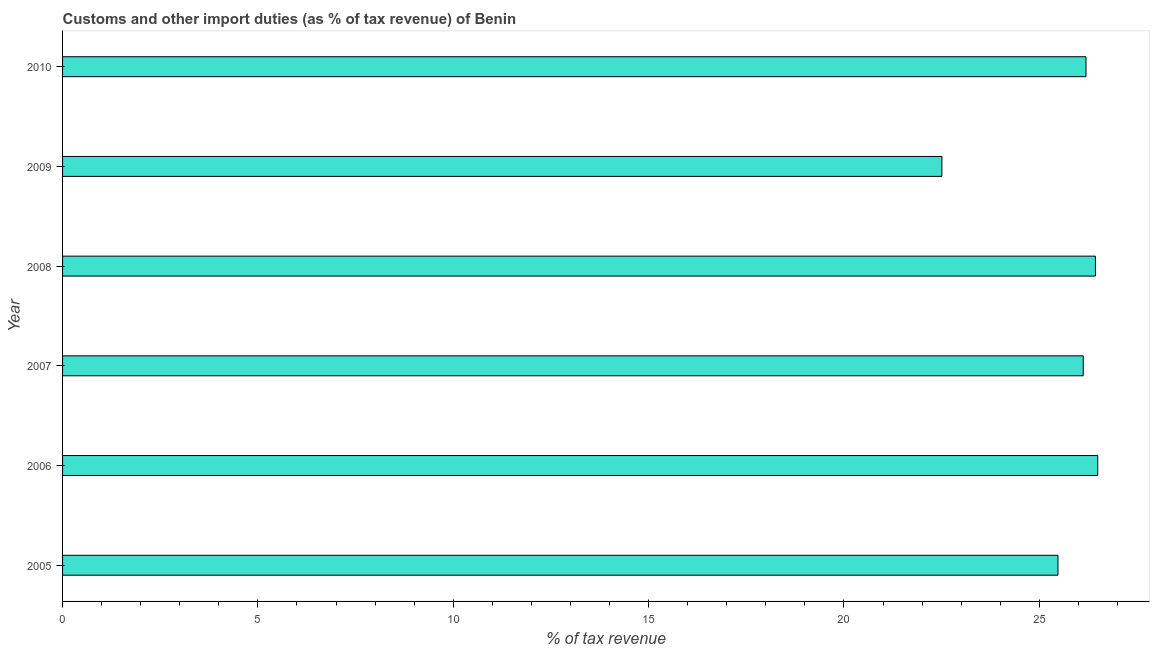What is the title of the graph?
Provide a short and direct response. Customs and other import duties (as % of tax revenue) of Benin. What is the label or title of the X-axis?
Offer a very short reply. % of tax revenue. What is the label or title of the Y-axis?
Your answer should be very brief. Year. What is the customs and other import duties in 2007?
Provide a succinct answer. 26.12. Across all years, what is the maximum customs and other import duties?
Offer a very short reply. 26.5. Across all years, what is the minimum customs and other import duties?
Your response must be concise. 22.51. In which year was the customs and other import duties maximum?
Make the answer very short. 2006. In which year was the customs and other import duties minimum?
Offer a very short reply. 2009. What is the sum of the customs and other import duties?
Offer a very short reply. 153.23. What is the difference between the customs and other import duties in 2009 and 2010?
Keep it short and to the point. -3.69. What is the average customs and other import duties per year?
Your response must be concise. 25.54. What is the median customs and other import duties?
Your response must be concise. 26.16. Do a majority of the years between 2007 and 2010 (inclusive) have customs and other import duties greater than 8 %?
Your answer should be compact. Yes. What is the ratio of the customs and other import duties in 2005 to that in 2008?
Your answer should be compact. 0.96. Is the customs and other import duties in 2007 less than that in 2010?
Offer a very short reply. Yes. What is the difference between the highest and the second highest customs and other import duties?
Ensure brevity in your answer.  0.06. Is the sum of the customs and other import duties in 2008 and 2009 greater than the maximum customs and other import duties across all years?
Ensure brevity in your answer.  Yes. What is the difference between the highest and the lowest customs and other import duties?
Offer a terse response. 3.99. In how many years, is the customs and other import duties greater than the average customs and other import duties taken over all years?
Your answer should be compact. 4. Are the values on the major ticks of X-axis written in scientific E-notation?
Offer a very short reply. No. What is the % of tax revenue in 2005?
Make the answer very short. 25.48. What is the % of tax revenue in 2006?
Your answer should be compact. 26.5. What is the % of tax revenue of 2007?
Provide a short and direct response. 26.12. What is the % of tax revenue of 2008?
Keep it short and to the point. 26.44. What is the % of tax revenue in 2009?
Make the answer very short. 22.51. What is the % of tax revenue of 2010?
Keep it short and to the point. 26.19. What is the difference between the % of tax revenue in 2005 and 2006?
Provide a succinct answer. -1.02. What is the difference between the % of tax revenue in 2005 and 2007?
Your response must be concise. -0.65. What is the difference between the % of tax revenue in 2005 and 2008?
Ensure brevity in your answer.  -0.96. What is the difference between the % of tax revenue in 2005 and 2009?
Provide a succinct answer. 2.97. What is the difference between the % of tax revenue in 2005 and 2010?
Your answer should be very brief. -0.72. What is the difference between the % of tax revenue in 2006 and 2007?
Your answer should be very brief. 0.37. What is the difference between the % of tax revenue in 2006 and 2008?
Give a very brief answer. 0.06. What is the difference between the % of tax revenue in 2006 and 2009?
Offer a terse response. 3.99. What is the difference between the % of tax revenue in 2006 and 2010?
Give a very brief answer. 0.3. What is the difference between the % of tax revenue in 2007 and 2008?
Offer a very short reply. -0.31. What is the difference between the % of tax revenue in 2007 and 2009?
Your answer should be compact. 3.62. What is the difference between the % of tax revenue in 2007 and 2010?
Offer a very short reply. -0.07. What is the difference between the % of tax revenue in 2008 and 2009?
Offer a very short reply. 3.93. What is the difference between the % of tax revenue in 2008 and 2010?
Your answer should be very brief. 0.24. What is the difference between the % of tax revenue in 2009 and 2010?
Your response must be concise. -3.69. What is the ratio of the % of tax revenue in 2005 to that in 2008?
Keep it short and to the point. 0.96. What is the ratio of the % of tax revenue in 2005 to that in 2009?
Offer a terse response. 1.13. What is the ratio of the % of tax revenue in 2005 to that in 2010?
Offer a terse response. 0.97. What is the ratio of the % of tax revenue in 2006 to that in 2007?
Keep it short and to the point. 1.01. What is the ratio of the % of tax revenue in 2006 to that in 2009?
Offer a very short reply. 1.18. What is the ratio of the % of tax revenue in 2006 to that in 2010?
Your answer should be compact. 1.01. What is the ratio of the % of tax revenue in 2007 to that in 2009?
Offer a terse response. 1.16. What is the ratio of the % of tax revenue in 2008 to that in 2009?
Your answer should be compact. 1.18. What is the ratio of the % of tax revenue in 2008 to that in 2010?
Offer a terse response. 1.01. What is the ratio of the % of tax revenue in 2009 to that in 2010?
Ensure brevity in your answer.  0.86. 